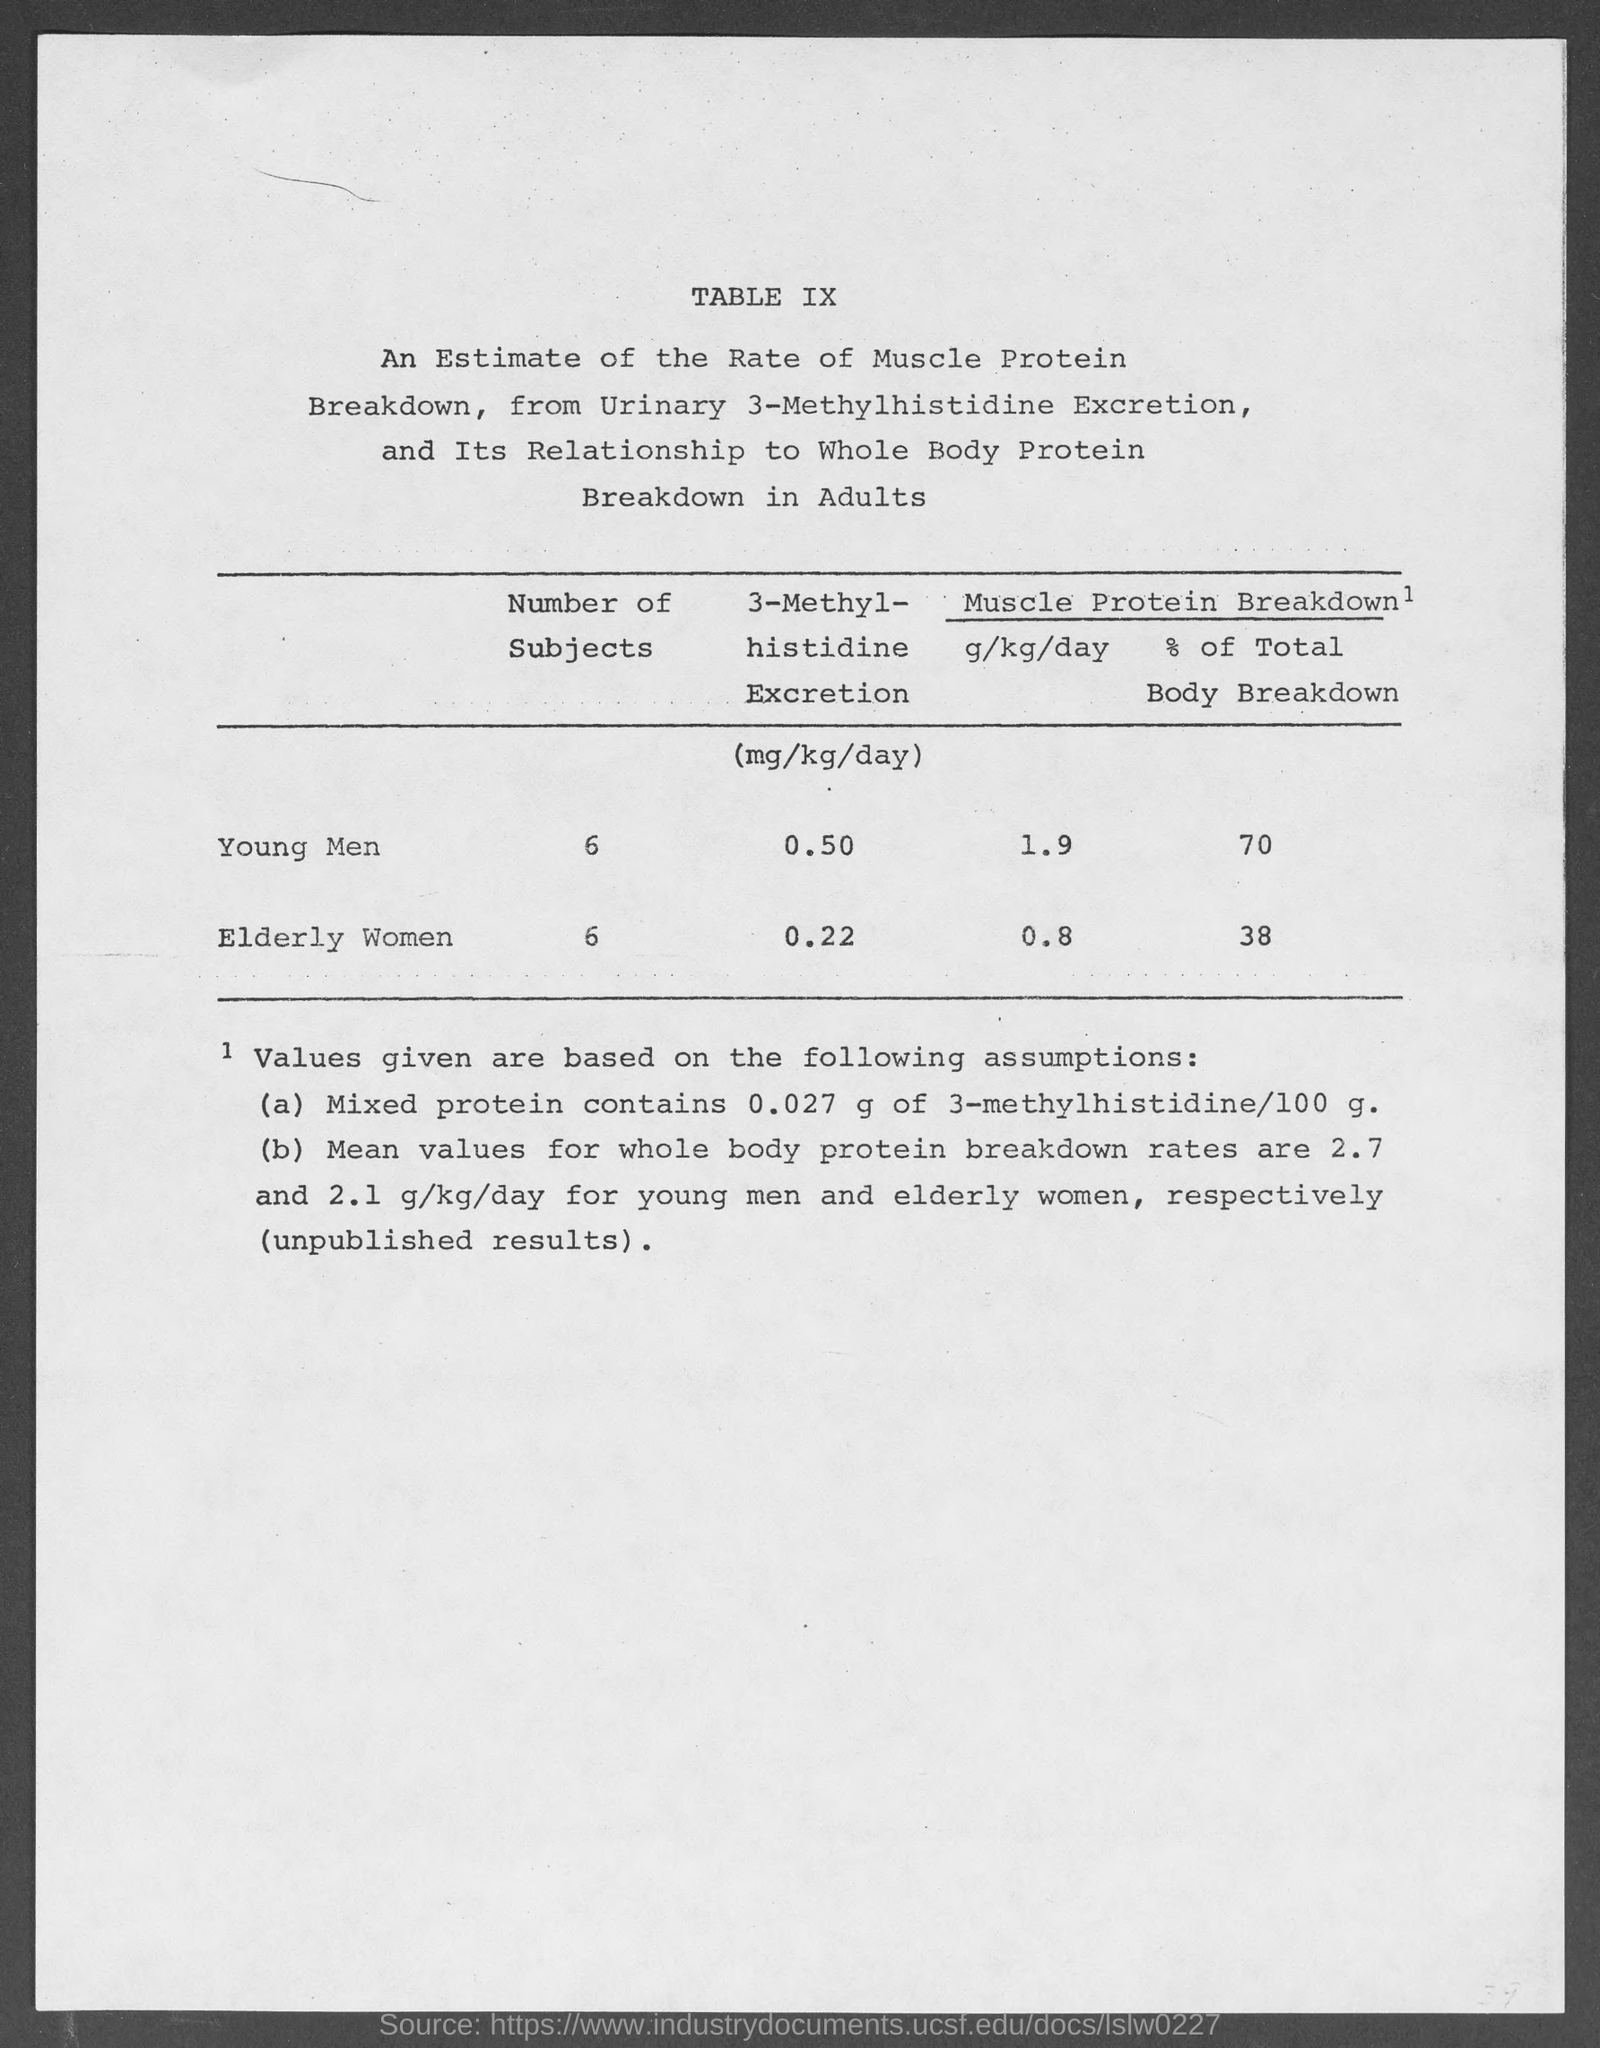List a handful of essential elements in this visual. The 3-methyl-histidine excretion in elderly women is 0.22 milligrams per kilogram per day. The excretion of 3-methyl-histidine in young men is approximately 0.50 milligrams per kilogram per day. The muscle protein breakdown in young men is approximately 1.9 grams per kilogram of body weight per day. The percentage of muscle protein breakdown in young men is approximately 70% of total body breakdown. There are six subjects in the group of elderly women. 